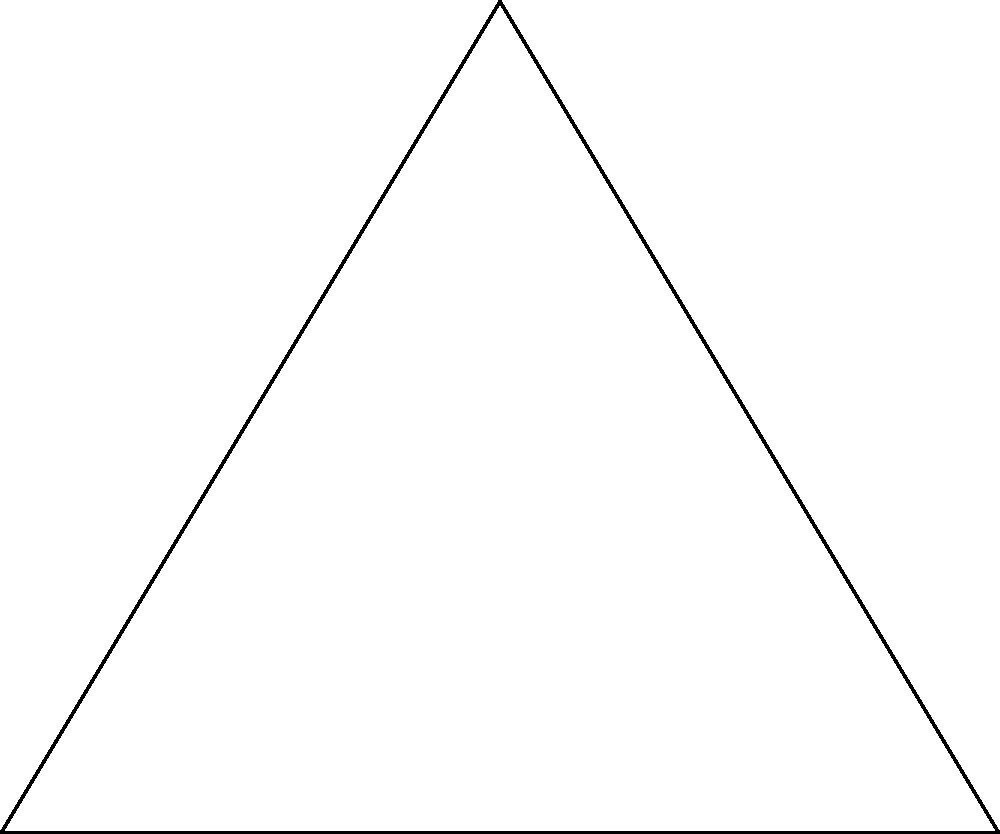Given three points in a 2D plane: $A(0,0)$, $B(6,0)$, and $C(3,5)$, find the coordinates of point $O$ that is equidistant from $A$, $B$, and $C$. Express your answer as a JSON object with 'x' and 'y' properties. To find the point $O$ equidistant from $A$, $B$, and $C$, we need to find the circumcenter of triangle $ABC$. Here's how:

1) The circumcenter is the intersection of the perpendicular bisectors of the triangle's sides.

2) For side $AB$:
   Midpoint: $(\frac{0+6}{2}, \frac{0+0}{2}) = (3,0)$
   Slope of $AB$: 0
   Perpendicular slope: undefined (vertical line)
   Equation: $x = 3$

3) For side $BC$:
   Midpoint: $(\frac{6+3}{2}, \frac{0+5}{2}) = (4.5, 2.5)$
   Slope of $BC$: $\frac{5-0}{3-6} = -\frac{5}{3}$
   Perpendicular slope: $\frac{3}{5}$
   Equation: $y - 2.5 = \frac{3}{5}(x - 4.5)$

4) Solve the system of equations:
   $x = 3$
   $y - 2.5 = \frac{3}{5}(3 - 4.5) = -0.9$
   $y = 1.6$

5) Therefore, the coordinates of $O$ are $(3, 1.6)$.

6) Express as a JSON object: `{"x": 3, "y": 1.6}`
Answer: {"x": 3, "y": 1.6} 